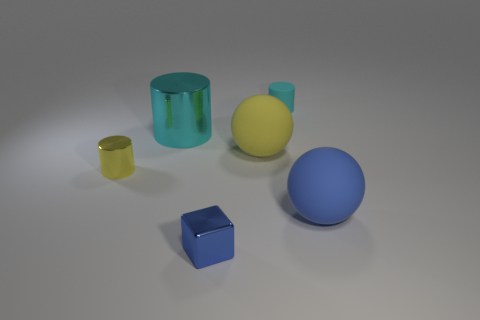Add 3 tiny metal cylinders. How many objects exist? 9 Subtract all balls. How many objects are left? 4 Subtract all big blue rubber spheres. Subtract all big rubber spheres. How many objects are left? 3 Add 2 small cyan cylinders. How many small cyan cylinders are left? 3 Add 1 cyan rubber objects. How many cyan rubber objects exist? 2 Subtract 1 yellow cylinders. How many objects are left? 5 